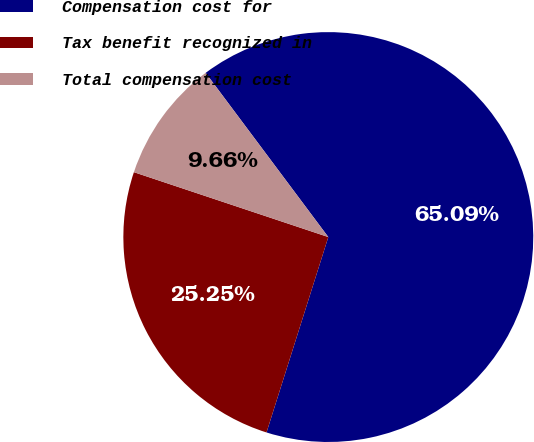<chart> <loc_0><loc_0><loc_500><loc_500><pie_chart><fcel>Compensation cost for<fcel>Tax benefit recognized in<fcel>Total compensation cost<nl><fcel>65.08%<fcel>25.25%<fcel>9.66%<nl></chart> 